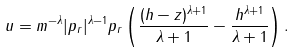<formula> <loc_0><loc_0><loc_500><loc_500>u = m ^ { - \lambda } | p _ { r } | ^ { \lambda - 1 } p _ { r } \left ( \frac { ( h - z ) ^ { \lambda + 1 } } { \lambda + 1 } - \frac { h ^ { \lambda + 1 } } { \lambda + 1 } \right ) .</formula> 